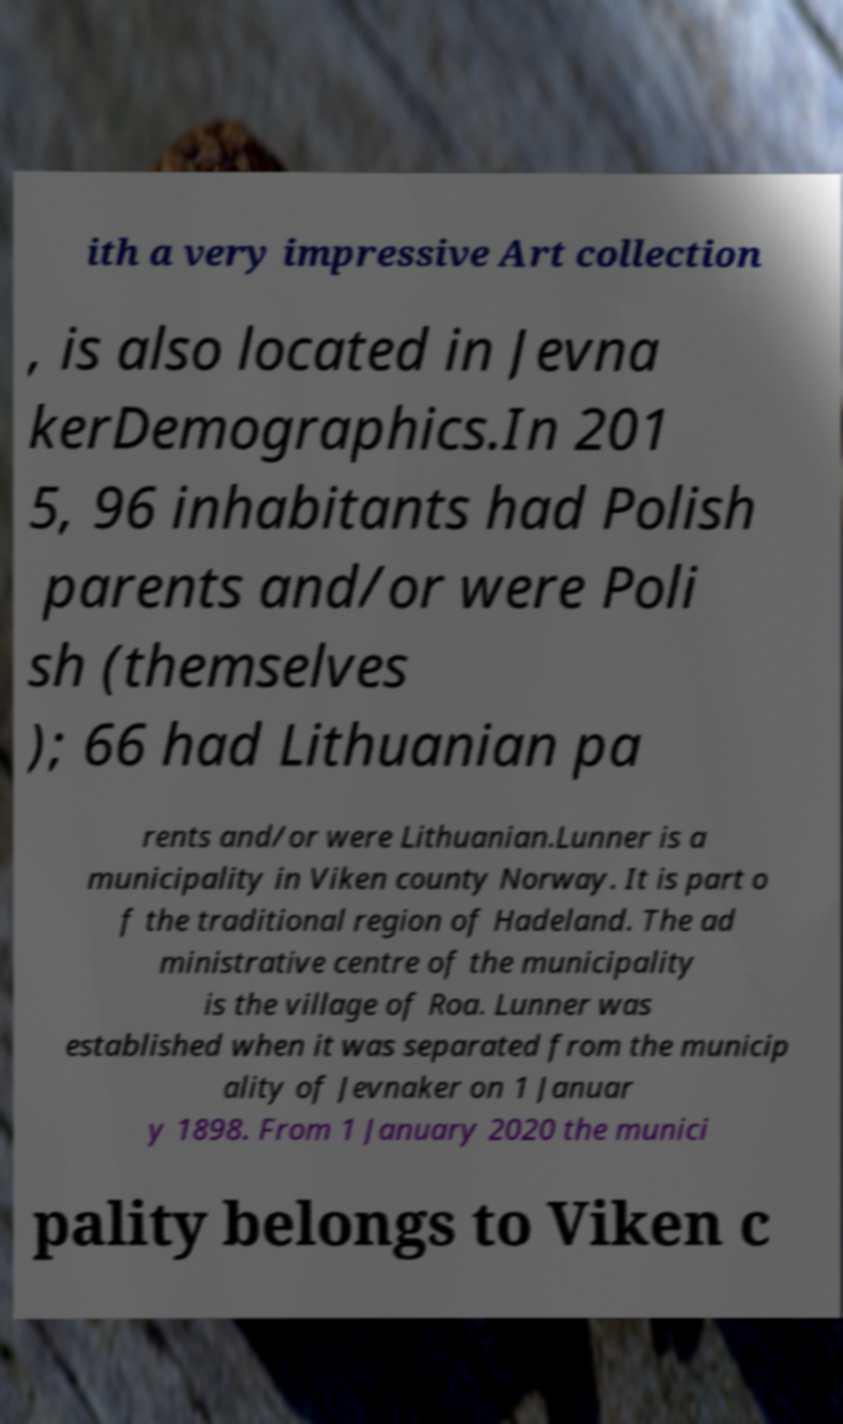Please read and relay the text visible in this image. What does it say? ith a very impressive Art collection , is also located in Jevna kerDemographics.In 201 5, 96 inhabitants had Polish parents and/or were Poli sh (themselves ); 66 had Lithuanian pa rents and/or were Lithuanian.Lunner is a municipality in Viken county Norway. It is part o f the traditional region of Hadeland. The ad ministrative centre of the municipality is the village of Roa. Lunner was established when it was separated from the municip ality of Jevnaker on 1 Januar y 1898. From 1 January 2020 the munici pality belongs to Viken c 